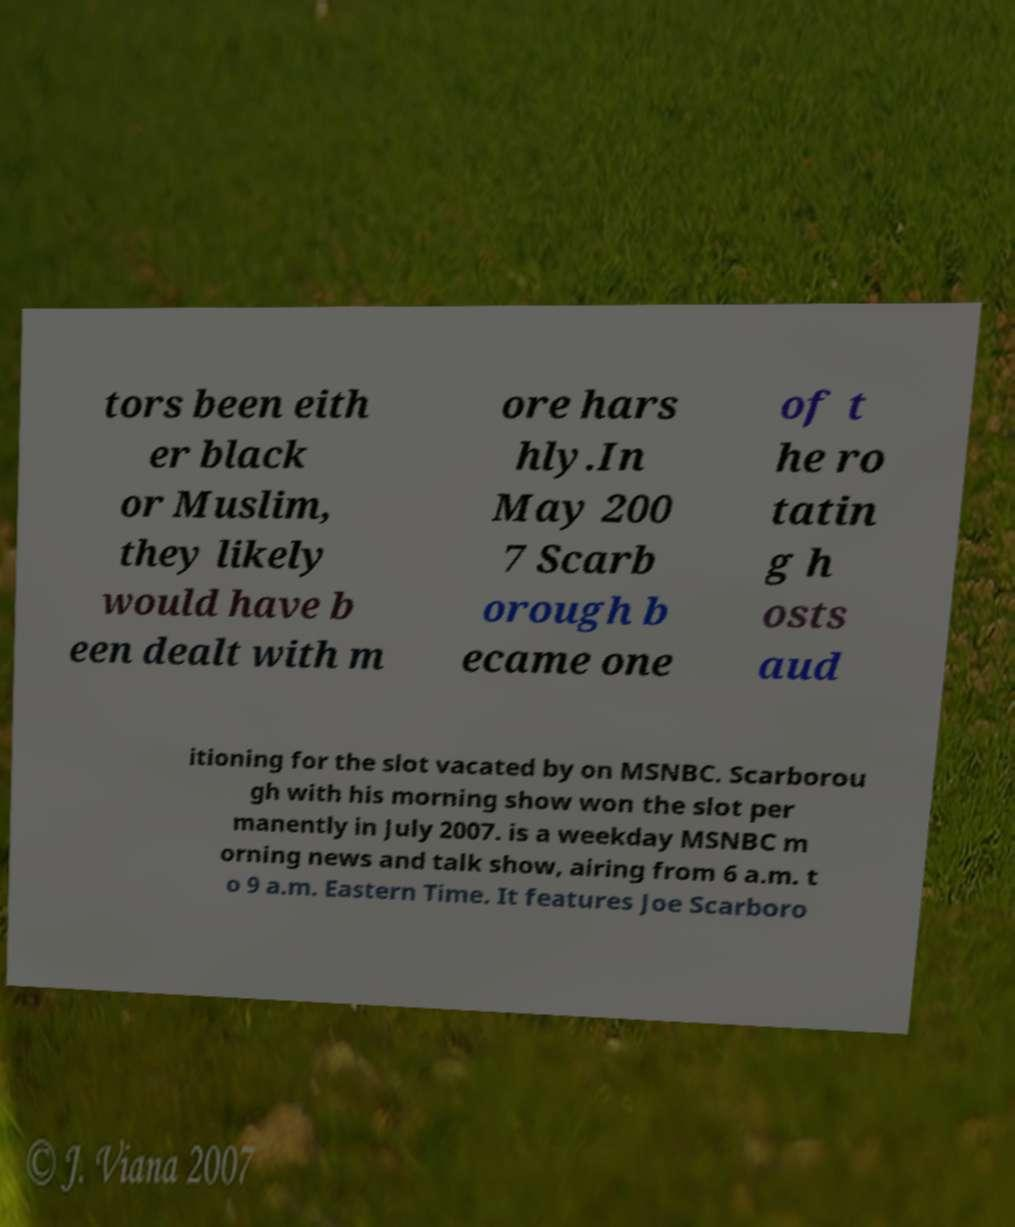I need the written content from this picture converted into text. Can you do that? tors been eith er black or Muslim, they likely would have b een dealt with m ore hars hly.In May 200 7 Scarb orough b ecame one of t he ro tatin g h osts aud itioning for the slot vacated by on MSNBC. Scarborou gh with his morning show won the slot per manently in July 2007. is a weekday MSNBC m orning news and talk show, airing from 6 a.m. t o 9 a.m. Eastern Time. It features Joe Scarboro 